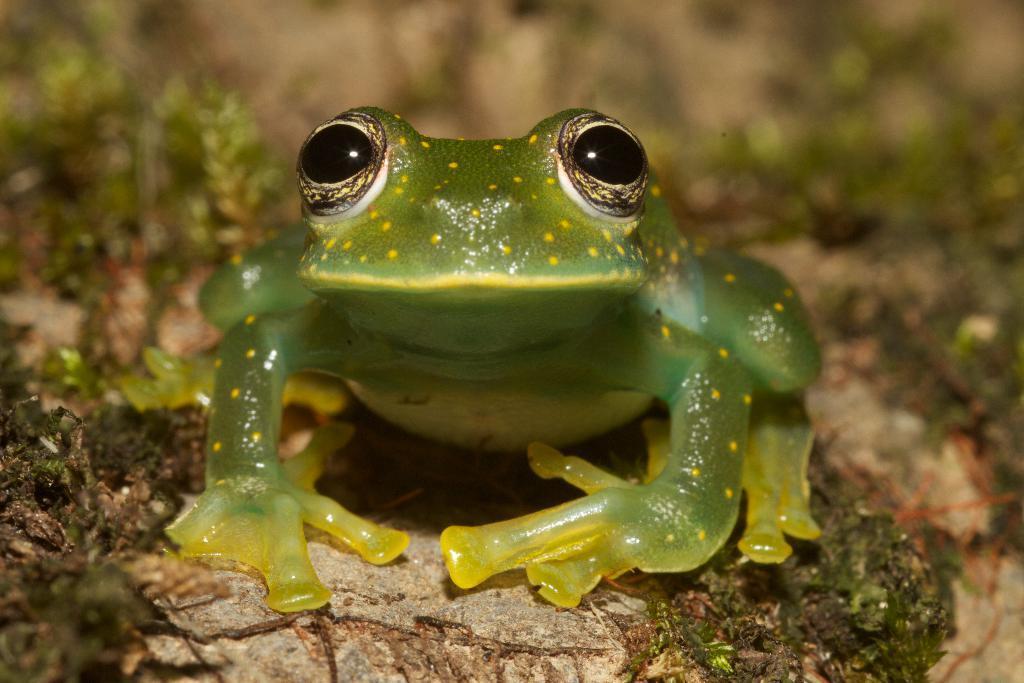How would you summarize this image in a sentence or two? In the image in the center we can see one frog,which is in green color. In the background we can see plants. 